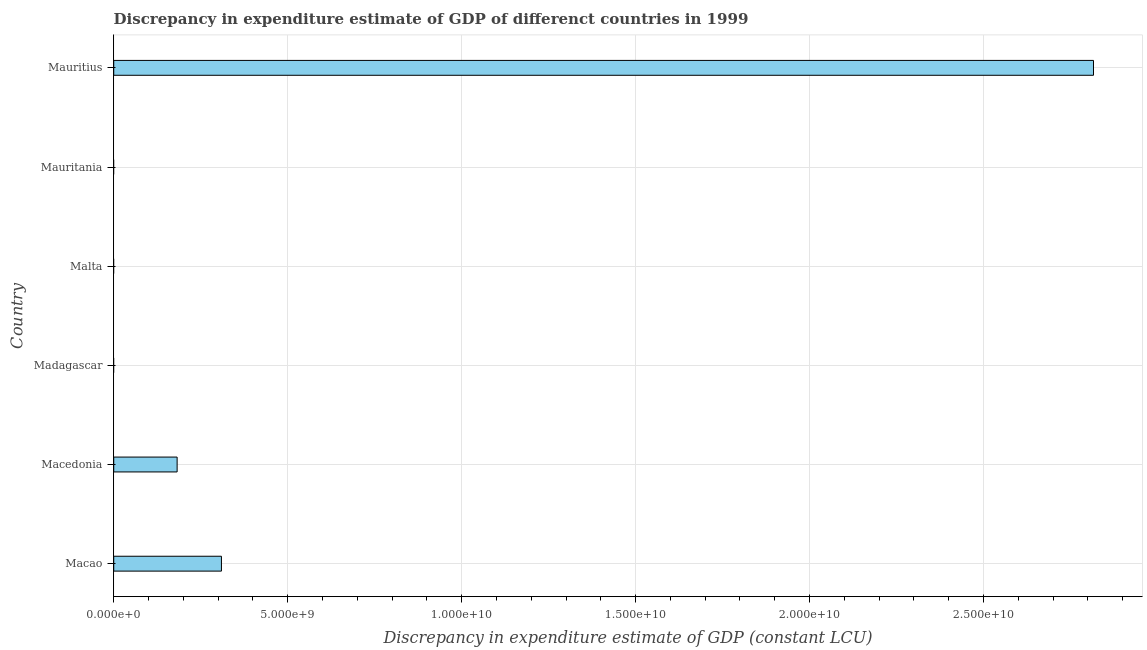What is the title of the graph?
Your answer should be very brief. Discrepancy in expenditure estimate of GDP of differenct countries in 1999. What is the label or title of the X-axis?
Offer a terse response. Discrepancy in expenditure estimate of GDP (constant LCU). What is the label or title of the Y-axis?
Your response must be concise. Country. Across all countries, what is the maximum discrepancy in expenditure estimate of gdp?
Your response must be concise. 2.82e+1. Across all countries, what is the minimum discrepancy in expenditure estimate of gdp?
Provide a succinct answer. 0. In which country was the discrepancy in expenditure estimate of gdp maximum?
Provide a succinct answer. Mauritius. What is the sum of the discrepancy in expenditure estimate of gdp?
Keep it short and to the point. 3.31e+1. What is the difference between the discrepancy in expenditure estimate of gdp in Macao and Macedonia?
Keep it short and to the point. 1.27e+09. What is the average discrepancy in expenditure estimate of gdp per country?
Your response must be concise. 5.51e+09. What is the median discrepancy in expenditure estimate of gdp?
Your response must be concise. 9.11e+08. In how many countries, is the discrepancy in expenditure estimate of gdp greater than 4000000000 LCU?
Make the answer very short. 1. What is the ratio of the discrepancy in expenditure estimate of gdp in Macao to that in Macedonia?
Keep it short and to the point. 1.7. Is the discrepancy in expenditure estimate of gdp in Macao less than that in Mauritius?
Make the answer very short. Yes. What is the difference between the highest and the second highest discrepancy in expenditure estimate of gdp?
Provide a short and direct response. 2.51e+1. What is the difference between the highest and the lowest discrepancy in expenditure estimate of gdp?
Provide a succinct answer. 2.82e+1. How many bars are there?
Give a very brief answer. 3. How many countries are there in the graph?
Keep it short and to the point. 6. What is the Discrepancy in expenditure estimate of GDP (constant LCU) in Macao?
Provide a succinct answer. 3.10e+09. What is the Discrepancy in expenditure estimate of GDP (constant LCU) in Macedonia?
Provide a succinct answer. 1.82e+09. What is the Discrepancy in expenditure estimate of GDP (constant LCU) in Mauritius?
Ensure brevity in your answer.  2.82e+1. What is the difference between the Discrepancy in expenditure estimate of GDP (constant LCU) in Macao and Macedonia?
Your answer should be very brief. 1.27e+09. What is the difference between the Discrepancy in expenditure estimate of GDP (constant LCU) in Macao and Mauritius?
Your answer should be compact. -2.51e+1. What is the difference between the Discrepancy in expenditure estimate of GDP (constant LCU) in Macedonia and Mauritius?
Make the answer very short. -2.63e+1. What is the ratio of the Discrepancy in expenditure estimate of GDP (constant LCU) in Macao to that in Macedonia?
Make the answer very short. 1.7. What is the ratio of the Discrepancy in expenditure estimate of GDP (constant LCU) in Macao to that in Mauritius?
Your answer should be very brief. 0.11. What is the ratio of the Discrepancy in expenditure estimate of GDP (constant LCU) in Macedonia to that in Mauritius?
Your answer should be very brief. 0.07. 